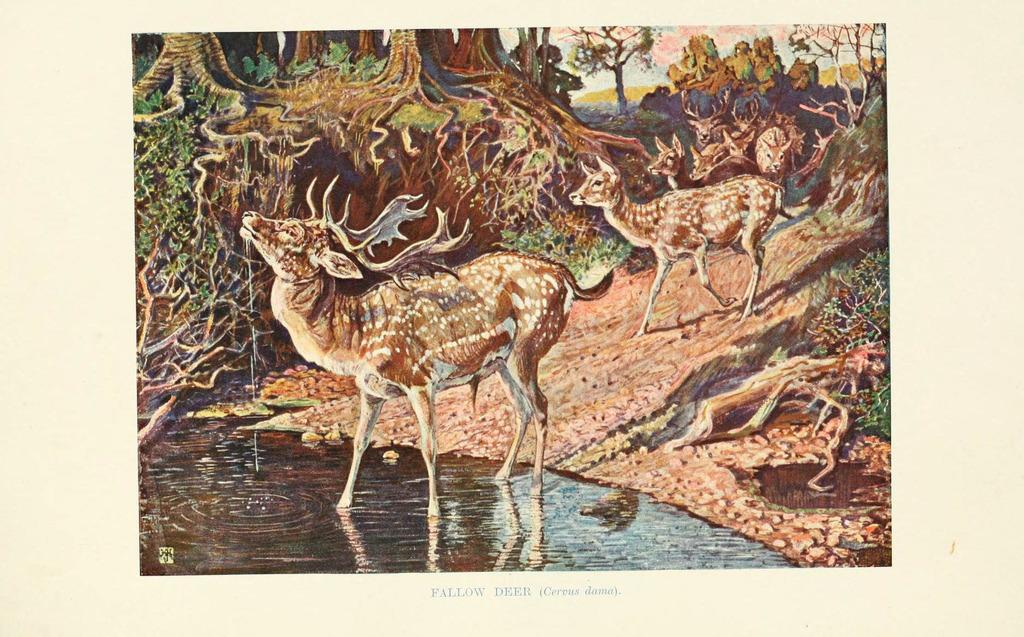What types of living organisms can be seen in the image? Animals and plants are visible in the image. What natural element is present in the image? Water is visible in the image. What type of vegetation is present in the image? Trees are present in the image. What type of peace symbol can be seen in the image? There is no peace symbol present in the image. Is there a woman driving a car in the image? There is no woman or car present in the image. 